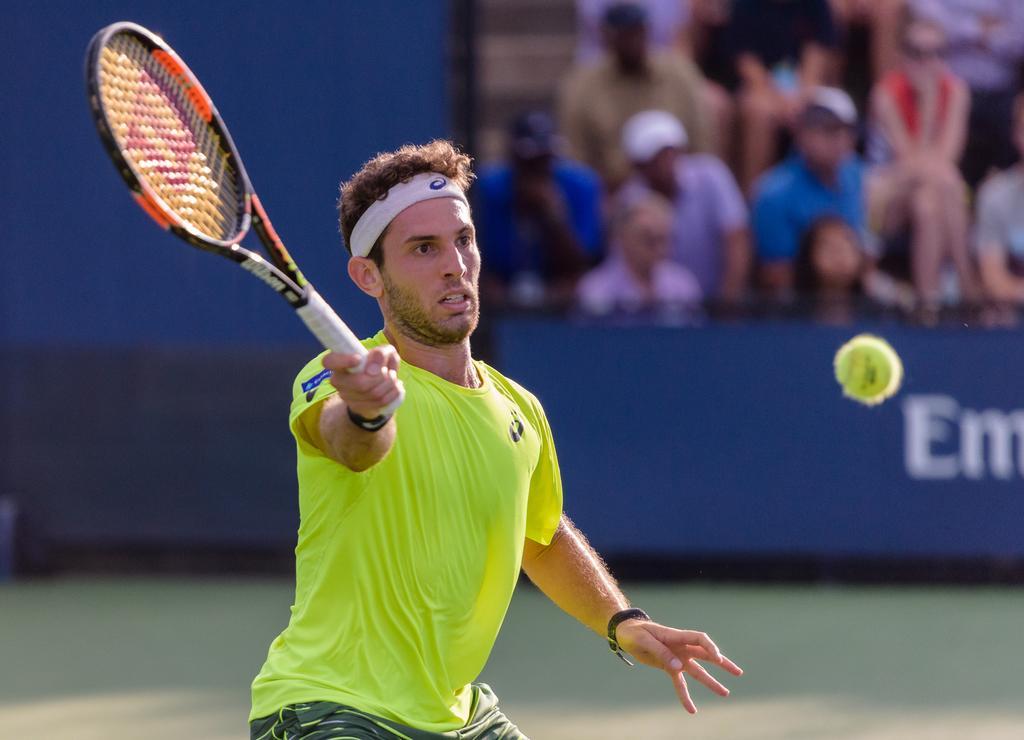Please provide a concise description of this image. In the image there is a person playing tennis, the ball is flying in the air and the man is holding the bat with his right hand and the background of the man is blur. 